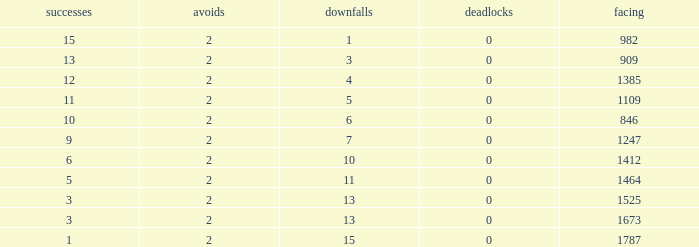What is the highest number listed under against when there were less than 3 wins and less than 15 losses? None. 